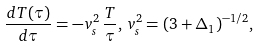Convert formula to latex. <formula><loc_0><loc_0><loc_500><loc_500>\frac { d T ( \tau ) } { d \tau } = - v ^ { 2 } _ { s } \, \frac { T } { \tau } , \, v ^ { 2 } _ { s } = ( 3 + \Delta _ { 1 } ) ^ { - 1 / 2 } ,</formula> 